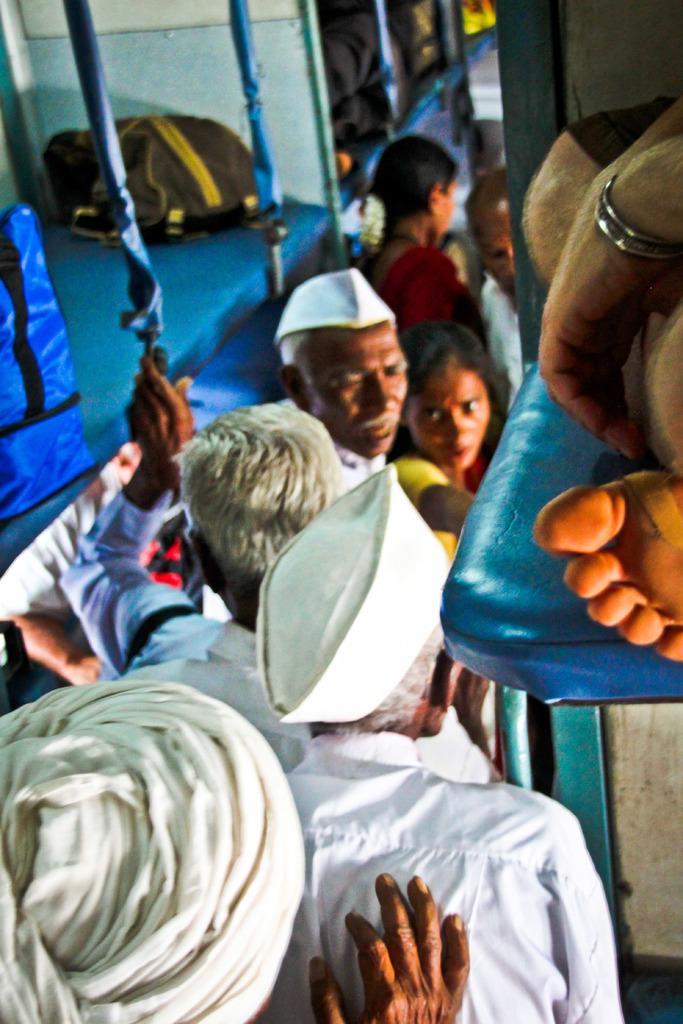Could you give a brief overview of what you see in this image? In the picture we can see a inside view of the train with some people standing and they are in white dresses and caps. 